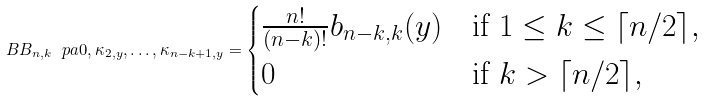Convert formula to latex. <formula><loc_0><loc_0><loc_500><loc_500>\ B B _ { n , k } \ p a { 0 , \kappa _ { 2 , y } , \dots , \kappa _ { n - k + 1 , y } } = \begin{cases} \frac { n ! } { ( n - k ) ! } b _ { n - k , k } ( y ) & \text {if $1 \leq k \leq \lceil n / 2 \rceil$} , \\ 0 & \text {if $k > \lceil n / 2 \rceil$} , \end{cases}</formula> 